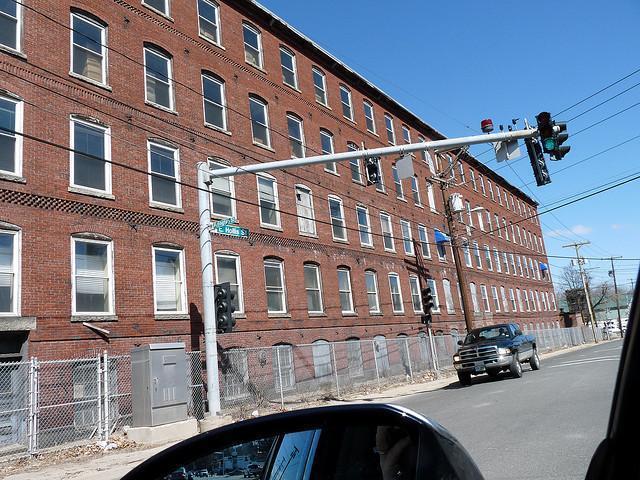What should the vehicle showing the side mirror do in this situation?
Indicate the correct response and explain using: 'Answer: answer
Rationale: rationale.'
Options: Turn right, turn left, stop, go. Answer: go.
Rationale: The green light tells the driver to continue. 